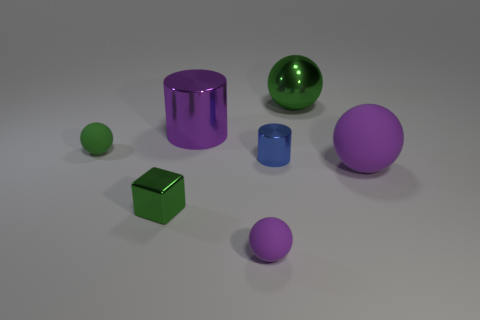Subtract all metal spheres. How many spheres are left? 3 Subtract all blue spheres. Subtract all red blocks. How many spheres are left? 4 Add 1 brown rubber blocks. How many objects exist? 8 Subtract all balls. How many objects are left? 3 Subtract all red metallic things. Subtract all tiny green rubber things. How many objects are left? 6 Add 7 blue metallic things. How many blue metallic things are left? 8 Add 5 big shiny cylinders. How many big shiny cylinders exist? 6 Subtract 0 cyan balls. How many objects are left? 7 